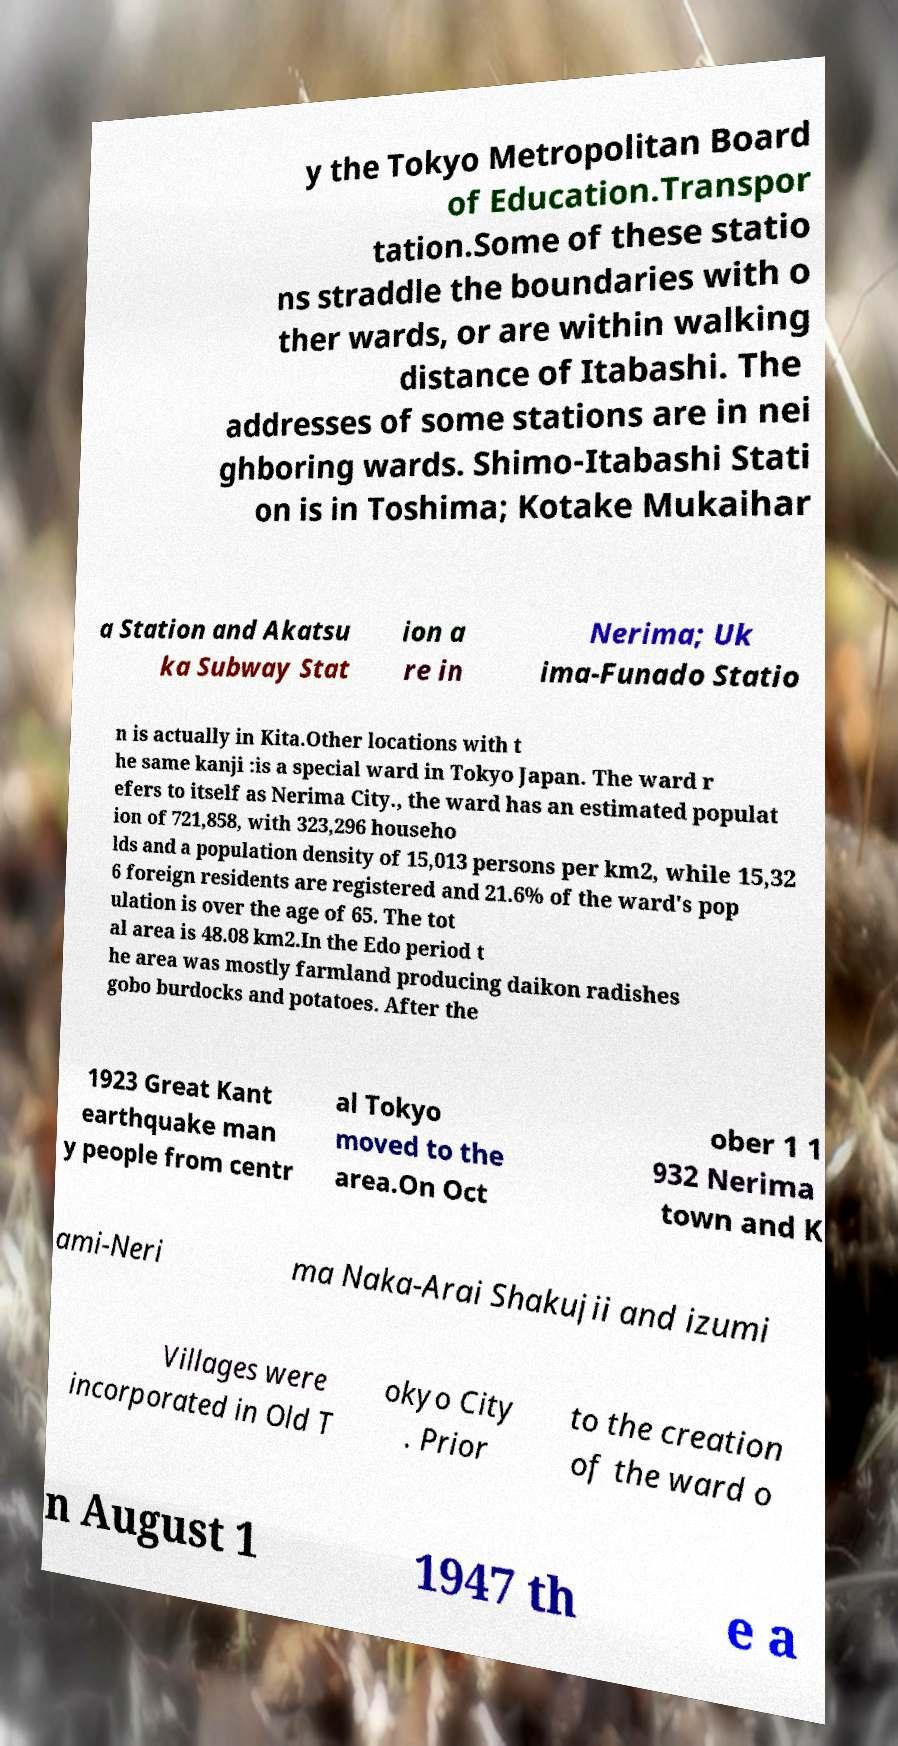Could you assist in decoding the text presented in this image and type it out clearly? y the Tokyo Metropolitan Board of Education.Transpor tation.Some of these statio ns straddle the boundaries with o ther wards, or are within walking distance of Itabashi. The addresses of some stations are in nei ghboring wards. Shimo-Itabashi Stati on is in Toshima; Kotake Mukaihar a Station and Akatsu ka Subway Stat ion a re in Nerima; Uk ima-Funado Statio n is actually in Kita.Other locations with t he same kanji :is a special ward in Tokyo Japan. The ward r efers to itself as Nerima City., the ward has an estimated populat ion of 721,858, with 323,296 househo lds and a population density of 15,013 persons per km2, while 15,32 6 foreign residents are registered and 21.6% of the ward's pop ulation is over the age of 65. The tot al area is 48.08 km2.In the Edo period t he area was mostly farmland producing daikon radishes gobo burdocks and potatoes. After the 1923 Great Kant earthquake man y people from centr al Tokyo moved to the area.On Oct ober 1 1 932 Nerima town and K ami-Neri ma Naka-Arai Shakujii and izumi Villages were incorporated in Old T okyo City . Prior to the creation of the ward o n August 1 1947 th e a 